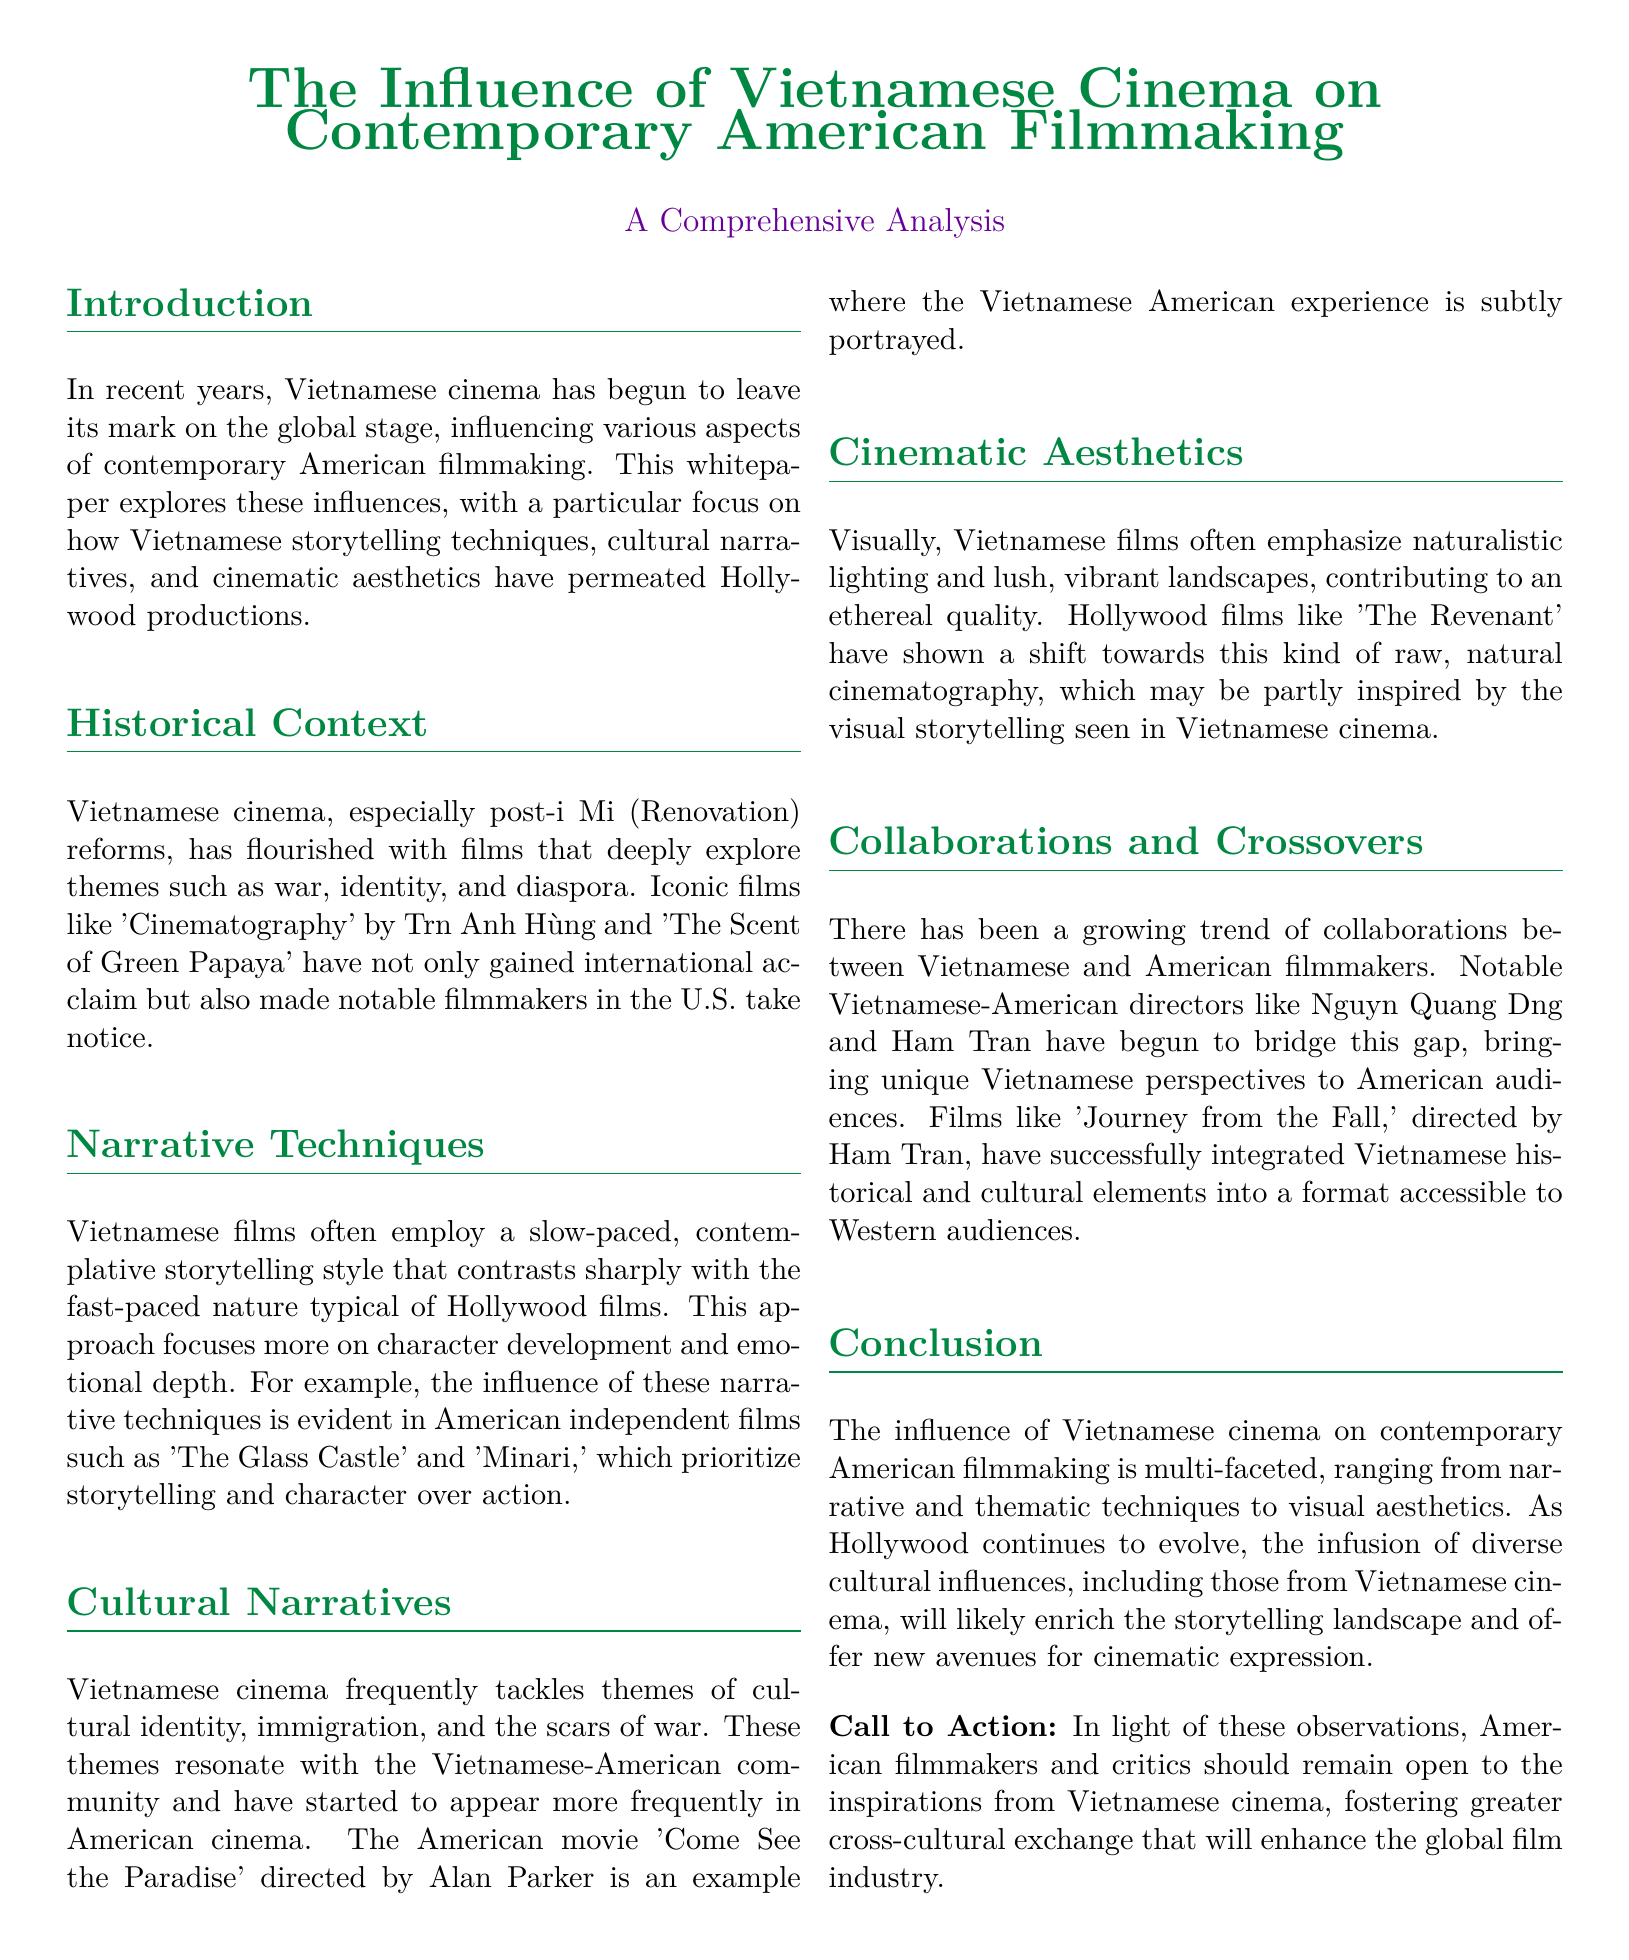What is the title of the whitepaper? The title of the whitepaper is prominently stated at the beginning, emphasizing its focus on Vietnamese cinema's influence.
Answer: The Influence of Vietnamese Cinema on Contemporary American Filmmaking What significant reforms are mentioned in the context of Vietnamese cinema? The document refers to post-Đổi Mới reforms as a pivotal time for Vietnamese cinema.
Answer: Đổi Mới Name one Vietnamese film that gained international acclaim. The whitepaper cites 'The Scent of Green Papaya' as an iconic film that has been recognized globally.
Answer: The Scent of Green Papaya What type of storytelling style is often employed in Vietnamese films? The discussion in the document highlights a slow-paced, contemplative storytelling style as characteristic of Vietnamese cinema.
Answer: Slow-paced Which American film is noted for prioritizing storytelling and character? 'Minari' is specifically mentioned in the context of how Vietnamese narrative techniques have influenced American independent films.
Answer: Minari What themes resonate with the Vietnamese-American community? The whitepaper states that themes of cultural identity, immigration, and the scars of war are significant for this community.
Answer: Cultural identity, immigration, and the scars of war Who is a notable Vietnamese-American director mentioned in the whitepaper? The mention of Nguyễn Quang Dũng shows the importance of his contributions to the collaboration between Vietnamese and American filmmakers.
Answer: Nguyễn Quang Dũng What is a visual technique highlighted in Vietnamese films? Naturalistic lighting is emphasized as a key aesthetic element in Vietnamese cinema.
Answer: Naturalistic lighting What is the call to action mentioned in the conclusion? The call to action encourages filmmakers and critics to embrace inspirations from Vietnamese cinema to enhance the film industry.
Answer: Foster greater cross-cultural exchange How does the whitepaper categorize its structure? The document is structured into distinct sections such as Introduction, Historical Context, Narrative Techniques, and others, typical of a comprehensive analysis.
Answer: Sections 